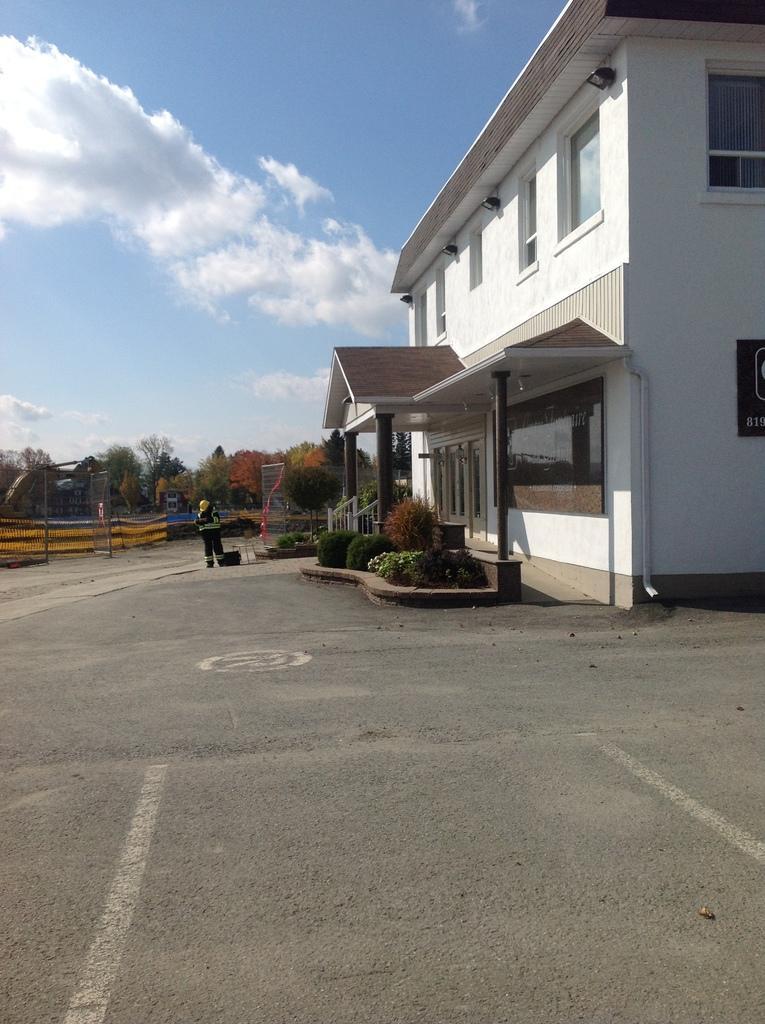Please provide a concise description of this image. In the picture we can see a building which is white in color with a glass window and some pillars near the path and some plants and in the background we can see some railing, trees, and sky with clouds. 